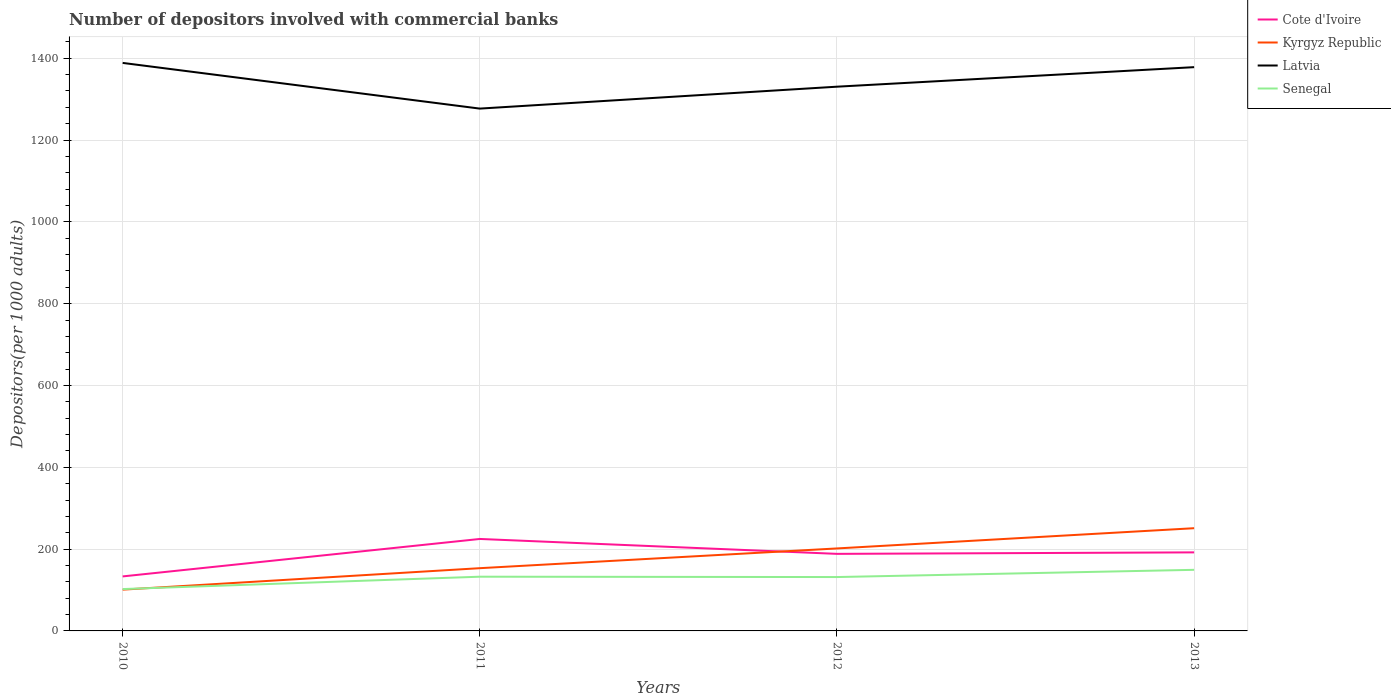Does the line corresponding to Senegal intersect with the line corresponding to Latvia?
Provide a succinct answer. No. Across all years, what is the maximum number of depositors involved with commercial banks in Cote d'Ivoire?
Keep it short and to the point. 133.26. What is the total number of depositors involved with commercial banks in Senegal in the graph?
Your response must be concise. -29.37. What is the difference between the highest and the second highest number of depositors involved with commercial banks in Senegal?
Your response must be concise. 47.01. How many years are there in the graph?
Offer a terse response. 4. Are the values on the major ticks of Y-axis written in scientific E-notation?
Your answer should be very brief. No. How are the legend labels stacked?
Provide a short and direct response. Vertical. What is the title of the graph?
Your answer should be very brief. Number of depositors involved with commercial banks. Does "Belarus" appear as one of the legend labels in the graph?
Offer a very short reply. No. What is the label or title of the X-axis?
Offer a very short reply. Years. What is the label or title of the Y-axis?
Keep it short and to the point. Depositors(per 1000 adults). What is the Depositors(per 1000 adults) in Cote d'Ivoire in 2010?
Provide a succinct answer. 133.26. What is the Depositors(per 1000 adults) in Kyrgyz Republic in 2010?
Make the answer very short. 100.91. What is the Depositors(per 1000 adults) in Latvia in 2010?
Offer a terse response. 1388.57. What is the Depositors(per 1000 adults) of Senegal in 2010?
Your answer should be compact. 102.32. What is the Depositors(per 1000 adults) of Cote d'Ivoire in 2011?
Keep it short and to the point. 224.81. What is the Depositors(per 1000 adults) in Kyrgyz Republic in 2011?
Offer a very short reply. 153.38. What is the Depositors(per 1000 adults) of Latvia in 2011?
Ensure brevity in your answer.  1276.88. What is the Depositors(per 1000 adults) of Senegal in 2011?
Keep it short and to the point. 132.54. What is the Depositors(per 1000 adults) of Cote d'Ivoire in 2012?
Your answer should be very brief. 188.4. What is the Depositors(per 1000 adults) of Kyrgyz Republic in 2012?
Your answer should be compact. 201.64. What is the Depositors(per 1000 adults) in Latvia in 2012?
Provide a short and direct response. 1330.45. What is the Depositors(per 1000 adults) of Senegal in 2012?
Provide a short and direct response. 131.69. What is the Depositors(per 1000 adults) of Cote d'Ivoire in 2013?
Offer a very short reply. 192.03. What is the Depositors(per 1000 adults) in Kyrgyz Republic in 2013?
Offer a terse response. 251.12. What is the Depositors(per 1000 adults) of Latvia in 2013?
Provide a succinct answer. 1378.2. What is the Depositors(per 1000 adults) of Senegal in 2013?
Provide a short and direct response. 149.33. Across all years, what is the maximum Depositors(per 1000 adults) of Cote d'Ivoire?
Give a very brief answer. 224.81. Across all years, what is the maximum Depositors(per 1000 adults) of Kyrgyz Republic?
Give a very brief answer. 251.12. Across all years, what is the maximum Depositors(per 1000 adults) of Latvia?
Provide a short and direct response. 1388.57. Across all years, what is the maximum Depositors(per 1000 adults) of Senegal?
Ensure brevity in your answer.  149.33. Across all years, what is the minimum Depositors(per 1000 adults) of Cote d'Ivoire?
Provide a short and direct response. 133.26. Across all years, what is the minimum Depositors(per 1000 adults) of Kyrgyz Republic?
Your response must be concise. 100.91. Across all years, what is the minimum Depositors(per 1000 adults) in Latvia?
Make the answer very short. 1276.88. Across all years, what is the minimum Depositors(per 1000 adults) of Senegal?
Your response must be concise. 102.32. What is the total Depositors(per 1000 adults) of Cote d'Ivoire in the graph?
Offer a terse response. 738.5. What is the total Depositors(per 1000 adults) in Kyrgyz Republic in the graph?
Give a very brief answer. 707.04. What is the total Depositors(per 1000 adults) of Latvia in the graph?
Ensure brevity in your answer.  5374.1. What is the total Depositors(per 1000 adults) in Senegal in the graph?
Your answer should be compact. 515.89. What is the difference between the Depositors(per 1000 adults) in Cote d'Ivoire in 2010 and that in 2011?
Provide a short and direct response. -91.56. What is the difference between the Depositors(per 1000 adults) of Kyrgyz Republic in 2010 and that in 2011?
Your response must be concise. -52.48. What is the difference between the Depositors(per 1000 adults) in Latvia in 2010 and that in 2011?
Your answer should be very brief. 111.69. What is the difference between the Depositors(per 1000 adults) in Senegal in 2010 and that in 2011?
Offer a very short reply. -30.21. What is the difference between the Depositors(per 1000 adults) in Cote d'Ivoire in 2010 and that in 2012?
Provide a succinct answer. -55.14. What is the difference between the Depositors(per 1000 adults) in Kyrgyz Republic in 2010 and that in 2012?
Offer a very short reply. -100.73. What is the difference between the Depositors(per 1000 adults) in Latvia in 2010 and that in 2012?
Give a very brief answer. 58.12. What is the difference between the Depositors(per 1000 adults) in Senegal in 2010 and that in 2012?
Provide a succinct answer. -29.37. What is the difference between the Depositors(per 1000 adults) of Cote d'Ivoire in 2010 and that in 2013?
Provide a succinct answer. -58.78. What is the difference between the Depositors(per 1000 adults) of Kyrgyz Republic in 2010 and that in 2013?
Offer a terse response. -150.21. What is the difference between the Depositors(per 1000 adults) in Latvia in 2010 and that in 2013?
Offer a terse response. 10.37. What is the difference between the Depositors(per 1000 adults) in Senegal in 2010 and that in 2013?
Your answer should be very brief. -47.01. What is the difference between the Depositors(per 1000 adults) in Cote d'Ivoire in 2011 and that in 2012?
Offer a terse response. 36.42. What is the difference between the Depositors(per 1000 adults) in Kyrgyz Republic in 2011 and that in 2012?
Provide a succinct answer. -48.25. What is the difference between the Depositors(per 1000 adults) in Latvia in 2011 and that in 2012?
Keep it short and to the point. -53.57. What is the difference between the Depositors(per 1000 adults) of Senegal in 2011 and that in 2012?
Offer a very short reply. 0.84. What is the difference between the Depositors(per 1000 adults) of Cote d'Ivoire in 2011 and that in 2013?
Your answer should be very brief. 32.78. What is the difference between the Depositors(per 1000 adults) in Kyrgyz Republic in 2011 and that in 2013?
Your answer should be very brief. -97.73. What is the difference between the Depositors(per 1000 adults) in Latvia in 2011 and that in 2013?
Offer a very short reply. -101.32. What is the difference between the Depositors(per 1000 adults) of Senegal in 2011 and that in 2013?
Your response must be concise. -16.8. What is the difference between the Depositors(per 1000 adults) in Cote d'Ivoire in 2012 and that in 2013?
Provide a short and direct response. -3.63. What is the difference between the Depositors(per 1000 adults) of Kyrgyz Republic in 2012 and that in 2013?
Make the answer very short. -49.48. What is the difference between the Depositors(per 1000 adults) in Latvia in 2012 and that in 2013?
Provide a succinct answer. -47.75. What is the difference between the Depositors(per 1000 adults) in Senegal in 2012 and that in 2013?
Give a very brief answer. -17.64. What is the difference between the Depositors(per 1000 adults) of Cote d'Ivoire in 2010 and the Depositors(per 1000 adults) of Kyrgyz Republic in 2011?
Your response must be concise. -20.13. What is the difference between the Depositors(per 1000 adults) of Cote d'Ivoire in 2010 and the Depositors(per 1000 adults) of Latvia in 2011?
Make the answer very short. -1143.62. What is the difference between the Depositors(per 1000 adults) of Cote d'Ivoire in 2010 and the Depositors(per 1000 adults) of Senegal in 2011?
Your answer should be very brief. 0.72. What is the difference between the Depositors(per 1000 adults) of Kyrgyz Republic in 2010 and the Depositors(per 1000 adults) of Latvia in 2011?
Offer a terse response. -1175.97. What is the difference between the Depositors(per 1000 adults) in Kyrgyz Republic in 2010 and the Depositors(per 1000 adults) in Senegal in 2011?
Provide a succinct answer. -31.63. What is the difference between the Depositors(per 1000 adults) of Latvia in 2010 and the Depositors(per 1000 adults) of Senegal in 2011?
Your answer should be very brief. 1256.03. What is the difference between the Depositors(per 1000 adults) in Cote d'Ivoire in 2010 and the Depositors(per 1000 adults) in Kyrgyz Republic in 2012?
Ensure brevity in your answer.  -68.38. What is the difference between the Depositors(per 1000 adults) in Cote d'Ivoire in 2010 and the Depositors(per 1000 adults) in Latvia in 2012?
Provide a succinct answer. -1197.19. What is the difference between the Depositors(per 1000 adults) in Cote d'Ivoire in 2010 and the Depositors(per 1000 adults) in Senegal in 2012?
Ensure brevity in your answer.  1.56. What is the difference between the Depositors(per 1000 adults) of Kyrgyz Republic in 2010 and the Depositors(per 1000 adults) of Latvia in 2012?
Your answer should be compact. -1229.54. What is the difference between the Depositors(per 1000 adults) of Kyrgyz Republic in 2010 and the Depositors(per 1000 adults) of Senegal in 2012?
Ensure brevity in your answer.  -30.79. What is the difference between the Depositors(per 1000 adults) in Latvia in 2010 and the Depositors(per 1000 adults) in Senegal in 2012?
Make the answer very short. 1256.87. What is the difference between the Depositors(per 1000 adults) in Cote d'Ivoire in 2010 and the Depositors(per 1000 adults) in Kyrgyz Republic in 2013?
Provide a short and direct response. -117.86. What is the difference between the Depositors(per 1000 adults) of Cote d'Ivoire in 2010 and the Depositors(per 1000 adults) of Latvia in 2013?
Ensure brevity in your answer.  -1244.95. What is the difference between the Depositors(per 1000 adults) in Cote d'Ivoire in 2010 and the Depositors(per 1000 adults) in Senegal in 2013?
Make the answer very short. -16.08. What is the difference between the Depositors(per 1000 adults) in Kyrgyz Republic in 2010 and the Depositors(per 1000 adults) in Latvia in 2013?
Provide a short and direct response. -1277.3. What is the difference between the Depositors(per 1000 adults) in Kyrgyz Republic in 2010 and the Depositors(per 1000 adults) in Senegal in 2013?
Provide a succinct answer. -48.43. What is the difference between the Depositors(per 1000 adults) of Latvia in 2010 and the Depositors(per 1000 adults) of Senegal in 2013?
Provide a succinct answer. 1239.24. What is the difference between the Depositors(per 1000 adults) in Cote d'Ivoire in 2011 and the Depositors(per 1000 adults) in Kyrgyz Republic in 2012?
Your answer should be compact. 23.18. What is the difference between the Depositors(per 1000 adults) of Cote d'Ivoire in 2011 and the Depositors(per 1000 adults) of Latvia in 2012?
Your answer should be very brief. -1105.63. What is the difference between the Depositors(per 1000 adults) in Cote d'Ivoire in 2011 and the Depositors(per 1000 adults) in Senegal in 2012?
Make the answer very short. 93.12. What is the difference between the Depositors(per 1000 adults) in Kyrgyz Republic in 2011 and the Depositors(per 1000 adults) in Latvia in 2012?
Provide a succinct answer. -1177.07. What is the difference between the Depositors(per 1000 adults) of Kyrgyz Republic in 2011 and the Depositors(per 1000 adults) of Senegal in 2012?
Ensure brevity in your answer.  21.69. What is the difference between the Depositors(per 1000 adults) of Latvia in 2011 and the Depositors(per 1000 adults) of Senegal in 2012?
Make the answer very short. 1145.18. What is the difference between the Depositors(per 1000 adults) of Cote d'Ivoire in 2011 and the Depositors(per 1000 adults) of Kyrgyz Republic in 2013?
Your response must be concise. -26.3. What is the difference between the Depositors(per 1000 adults) in Cote d'Ivoire in 2011 and the Depositors(per 1000 adults) in Latvia in 2013?
Your answer should be very brief. -1153.39. What is the difference between the Depositors(per 1000 adults) in Cote d'Ivoire in 2011 and the Depositors(per 1000 adults) in Senegal in 2013?
Ensure brevity in your answer.  75.48. What is the difference between the Depositors(per 1000 adults) in Kyrgyz Republic in 2011 and the Depositors(per 1000 adults) in Latvia in 2013?
Offer a terse response. -1224.82. What is the difference between the Depositors(per 1000 adults) in Kyrgyz Republic in 2011 and the Depositors(per 1000 adults) in Senegal in 2013?
Your answer should be very brief. 4.05. What is the difference between the Depositors(per 1000 adults) of Latvia in 2011 and the Depositors(per 1000 adults) of Senegal in 2013?
Offer a very short reply. 1127.55. What is the difference between the Depositors(per 1000 adults) in Cote d'Ivoire in 2012 and the Depositors(per 1000 adults) in Kyrgyz Republic in 2013?
Ensure brevity in your answer.  -62.72. What is the difference between the Depositors(per 1000 adults) in Cote d'Ivoire in 2012 and the Depositors(per 1000 adults) in Latvia in 2013?
Your answer should be very brief. -1189.8. What is the difference between the Depositors(per 1000 adults) of Cote d'Ivoire in 2012 and the Depositors(per 1000 adults) of Senegal in 2013?
Keep it short and to the point. 39.07. What is the difference between the Depositors(per 1000 adults) in Kyrgyz Republic in 2012 and the Depositors(per 1000 adults) in Latvia in 2013?
Give a very brief answer. -1176.57. What is the difference between the Depositors(per 1000 adults) in Kyrgyz Republic in 2012 and the Depositors(per 1000 adults) in Senegal in 2013?
Make the answer very short. 52.3. What is the difference between the Depositors(per 1000 adults) of Latvia in 2012 and the Depositors(per 1000 adults) of Senegal in 2013?
Your answer should be compact. 1181.12. What is the average Depositors(per 1000 adults) in Cote d'Ivoire per year?
Ensure brevity in your answer.  184.62. What is the average Depositors(per 1000 adults) of Kyrgyz Republic per year?
Make the answer very short. 176.76. What is the average Depositors(per 1000 adults) in Latvia per year?
Your response must be concise. 1343.52. What is the average Depositors(per 1000 adults) in Senegal per year?
Provide a short and direct response. 128.97. In the year 2010, what is the difference between the Depositors(per 1000 adults) of Cote d'Ivoire and Depositors(per 1000 adults) of Kyrgyz Republic?
Your answer should be very brief. 32.35. In the year 2010, what is the difference between the Depositors(per 1000 adults) in Cote d'Ivoire and Depositors(per 1000 adults) in Latvia?
Give a very brief answer. -1255.31. In the year 2010, what is the difference between the Depositors(per 1000 adults) in Cote d'Ivoire and Depositors(per 1000 adults) in Senegal?
Make the answer very short. 30.93. In the year 2010, what is the difference between the Depositors(per 1000 adults) in Kyrgyz Republic and Depositors(per 1000 adults) in Latvia?
Offer a terse response. -1287.66. In the year 2010, what is the difference between the Depositors(per 1000 adults) in Kyrgyz Republic and Depositors(per 1000 adults) in Senegal?
Your answer should be very brief. -1.42. In the year 2010, what is the difference between the Depositors(per 1000 adults) in Latvia and Depositors(per 1000 adults) in Senegal?
Give a very brief answer. 1286.24. In the year 2011, what is the difference between the Depositors(per 1000 adults) of Cote d'Ivoire and Depositors(per 1000 adults) of Kyrgyz Republic?
Ensure brevity in your answer.  71.43. In the year 2011, what is the difference between the Depositors(per 1000 adults) in Cote d'Ivoire and Depositors(per 1000 adults) in Latvia?
Provide a succinct answer. -1052.06. In the year 2011, what is the difference between the Depositors(per 1000 adults) in Cote d'Ivoire and Depositors(per 1000 adults) in Senegal?
Your answer should be compact. 92.28. In the year 2011, what is the difference between the Depositors(per 1000 adults) of Kyrgyz Republic and Depositors(per 1000 adults) of Latvia?
Provide a short and direct response. -1123.5. In the year 2011, what is the difference between the Depositors(per 1000 adults) in Kyrgyz Republic and Depositors(per 1000 adults) in Senegal?
Ensure brevity in your answer.  20.85. In the year 2011, what is the difference between the Depositors(per 1000 adults) of Latvia and Depositors(per 1000 adults) of Senegal?
Offer a terse response. 1144.34. In the year 2012, what is the difference between the Depositors(per 1000 adults) in Cote d'Ivoire and Depositors(per 1000 adults) in Kyrgyz Republic?
Provide a short and direct response. -13.24. In the year 2012, what is the difference between the Depositors(per 1000 adults) in Cote d'Ivoire and Depositors(per 1000 adults) in Latvia?
Offer a very short reply. -1142.05. In the year 2012, what is the difference between the Depositors(per 1000 adults) of Cote d'Ivoire and Depositors(per 1000 adults) of Senegal?
Your answer should be very brief. 56.7. In the year 2012, what is the difference between the Depositors(per 1000 adults) in Kyrgyz Republic and Depositors(per 1000 adults) in Latvia?
Provide a succinct answer. -1128.81. In the year 2012, what is the difference between the Depositors(per 1000 adults) in Kyrgyz Republic and Depositors(per 1000 adults) in Senegal?
Your response must be concise. 69.94. In the year 2012, what is the difference between the Depositors(per 1000 adults) of Latvia and Depositors(per 1000 adults) of Senegal?
Your answer should be very brief. 1198.75. In the year 2013, what is the difference between the Depositors(per 1000 adults) in Cote d'Ivoire and Depositors(per 1000 adults) in Kyrgyz Republic?
Ensure brevity in your answer.  -59.09. In the year 2013, what is the difference between the Depositors(per 1000 adults) in Cote d'Ivoire and Depositors(per 1000 adults) in Latvia?
Provide a succinct answer. -1186.17. In the year 2013, what is the difference between the Depositors(per 1000 adults) of Cote d'Ivoire and Depositors(per 1000 adults) of Senegal?
Offer a terse response. 42.7. In the year 2013, what is the difference between the Depositors(per 1000 adults) in Kyrgyz Republic and Depositors(per 1000 adults) in Latvia?
Ensure brevity in your answer.  -1127.09. In the year 2013, what is the difference between the Depositors(per 1000 adults) of Kyrgyz Republic and Depositors(per 1000 adults) of Senegal?
Your answer should be very brief. 101.78. In the year 2013, what is the difference between the Depositors(per 1000 adults) in Latvia and Depositors(per 1000 adults) in Senegal?
Make the answer very short. 1228.87. What is the ratio of the Depositors(per 1000 adults) of Cote d'Ivoire in 2010 to that in 2011?
Your answer should be very brief. 0.59. What is the ratio of the Depositors(per 1000 adults) in Kyrgyz Republic in 2010 to that in 2011?
Offer a terse response. 0.66. What is the ratio of the Depositors(per 1000 adults) of Latvia in 2010 to that in 2011?
Keep it short and to the point. 1.09. What is the ratio of the Depositors(per 1000 adults) of Senegal in 2010 to that in 2011?
Your response must be concise. 0.77. What is the ratio of the Depositors(per 1000 adults) of Cote d'Ivoire in 2010 to that in 2012?
Offer a very short reply. 0.71. What is the ratio of the Depositors(per 1000 adults) of Kyrgyz Republic in 2010 to that in 2012?
Keep it short and to the point. 0.5. What is the ratio of the Depositors(per 1000 adults) in Latvia in 2010 to that in 2012?
Your answer should be compact. 1.04. What is the ratio of the Depositors(per 1000 adults) of Senegal in 2010 to that in 2012?
Your answer should be very brief. 0.78. What is the ratio of the Depositors(per 1000 adults) of Cote d'Ivoire in 2010 to that in 2013?
Give a very brief answer. 0.69. What is the ratio of the Depositors(per 1000 adults) in Kyrgyz Republic in 2010 to that in 2013?
Provide a succinct answer. 0.4. What is the ratio of the Depositors(per 1000 adults) of Latvia in 2010 to that in 2013?
Your answer should be very brief. 1.01. What is the ratio of the Depositors(per 1000 adults) in Senegal in 2010 to that in 2013?
Provide a short and direct response. 0.69. What is the ratio of the Depositors(per 1000 adults) in Cote d'Ivoire in 2011 to that in 2012?
Make the answer very short. 1.19. What is the ratio of the Depositors(per 1000 adults) of Kyrgyz Republic in 2011 to that in 2012?
Your answer should be very brief. 0.76. What is the ratio of the Depositors(per 1000 adults) in Latvia in 2011 to that in 2012?
Provide a succinct answer. 0.96. What is the ratio of the Depositors(per 1000 adults) of Senegal in 2011 to that in 2012?
Make the answer very short. 1.01. What is the ratio of the Depositors(per 1000 adults) of Cote d'Ivoire in 2011 to that in 2013?
Give a very brief answer. 1.17. What is the ratio of the Depositors(per 1000 adults) of Kyrgyz Republic in 2011 to that in 2013?
Give a very brief answer. 0.61. What is the ratio of the Depositors(per 1000 adults) of Latvia in 2011 to that in 2013?
Provide a short and direct response. 0.93. What is the ratio of the Depositors(per 1000 adults) of Senegal in 2011 to that in 2013?
Make the answer very short. 0.89. What is the ratio of the Depositors(per 1000 adults) of Cote d'Ivoire in 2012 to that in 2013?
Your response must be concise. 0.98. What is the ratio of the Depositors(per 1000 adults) of Kyrgyz Republic in 2012 to that in 2013?
Your answer should be compact. 0.8. What is the ratio of the Depositors(per 1000 adults) in Latvia in 2012 to that in 2013?
Your answer should be very brief. 0.97. What is the ratio of the Depositors(per 1000 adults) in Senegal in 2012 to that in 2013?
Your answer should be compact. 0.88. What is the difference between the highest and the second highest Depositors(per 1000 adults) in Cote d'Ivoire?
Ensure brevity in your answer.  32.78. What is the difference between the highest and the second highest Depositors(per 1000 adults) in Kyrgyz Republic?
Keep it short and to the point. 49.48. What is the difference between the highest and the second highest Depositors(per 1000 adults) in Latvia?
Provide a succinct answer. 10.37. What is the difference between the highest and the second highest Depositors(per 1000 adults) of Senegal?
Keep it short and to the point. 16.8. What is the difference between the highest and the lowest Depositors(per 1000 adults) of Cote d'Ivoire?
Your answer should be very brief. 91.56. What is the difference between the highest and the lowest Depositors(per 1000 adults) in Kyrgyz Republic?
Give a very brief answer. 150.21. What is the difference between the highest and the lowest Depositors(per 1000 adults) of Latvia?
Your response must be concise. 111.69. What is the difference between the highest and the lowest Depositors(per 1000 adults) in Senegal?
Your answer should be very brief. 47.01. 